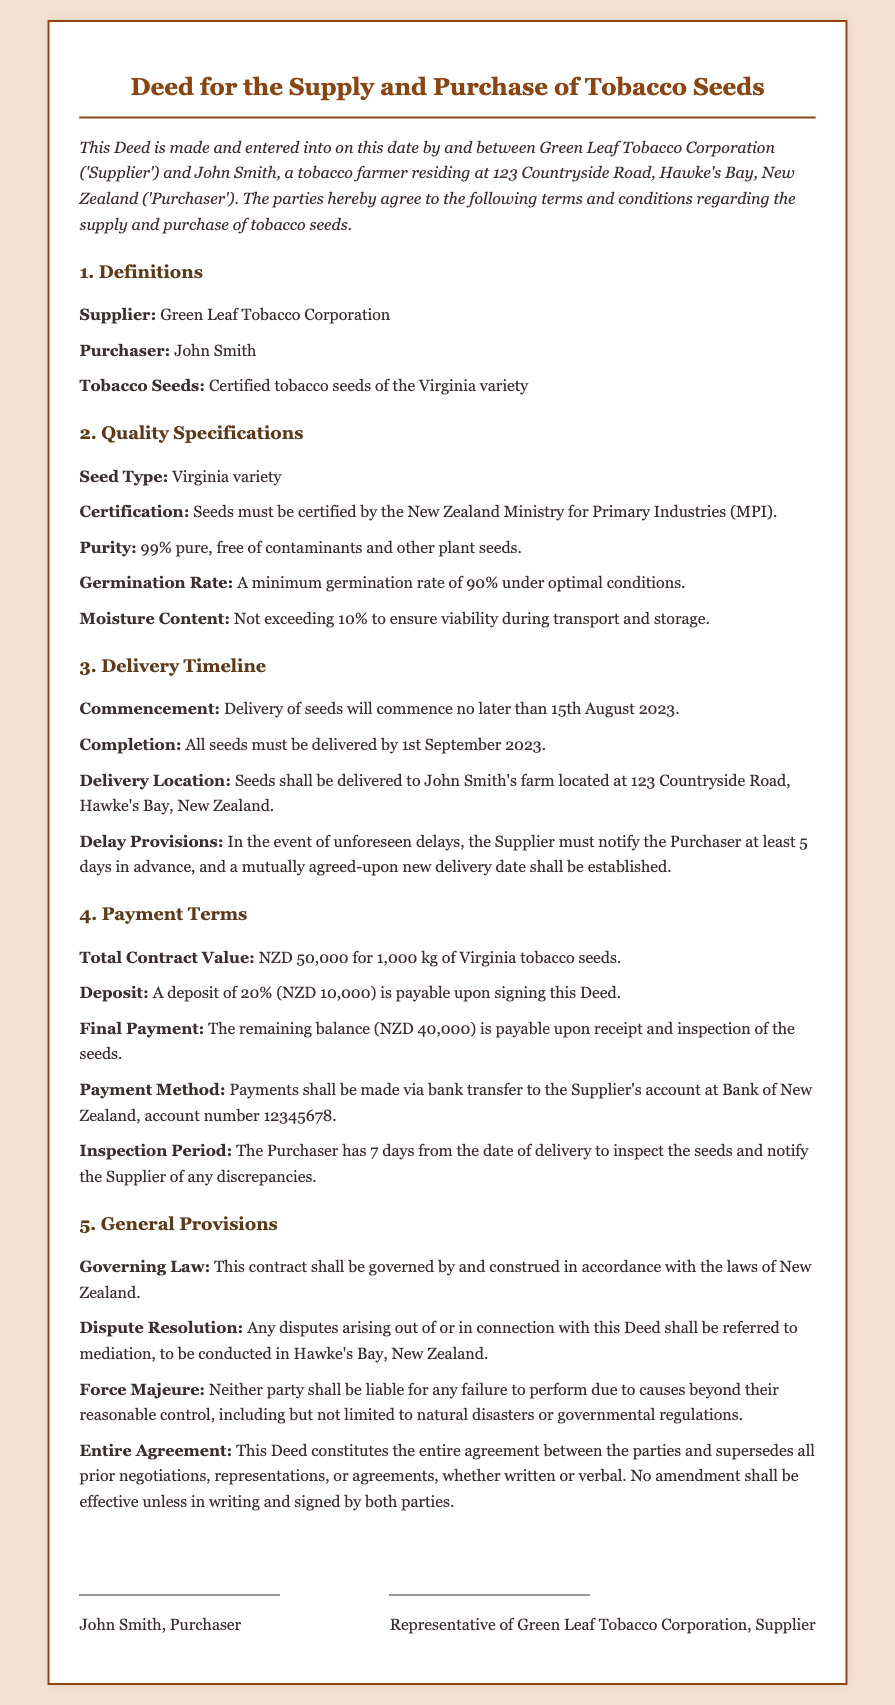What is the name of the Supplier? The Supplier is identified in the document as Green Leaf Tobacco Corporation.
Answer: Green Leaf Tobacco Corporation What is the total contract value? The total contract value is explicitly stated in the document as NZD 50,000 for 1,000 kg of seeds.
Answer: NZD 50,000 What is the minimum germination rate required? The document specifies that there must be a minimum germination rate of 90% under optimal conditions.
Answer: 90% When is the latest delivery completion date? The document indicates that all seeds must be delivered by 1st September 2023.
Answer: 1st September 2023 What percentage of deposit is required upon signing the Deed? The required deposit upon signing is 20% of the total contract value.
Answer: 20% What should the moisture content not exceed? It is stated in the document that the moisture content should not exceed 10%.
Answer: 10% What is the inspection period for the seeds? The document mentions that the Purchaser has 7 days from the delivery date for inspection.
Answer: 7 days What happens in the case of unforeseen delays? The document specifies that the Supplier must notify the Purchaser at least 5 days in advance of any unforeseen delays.
Answer: 5 days 